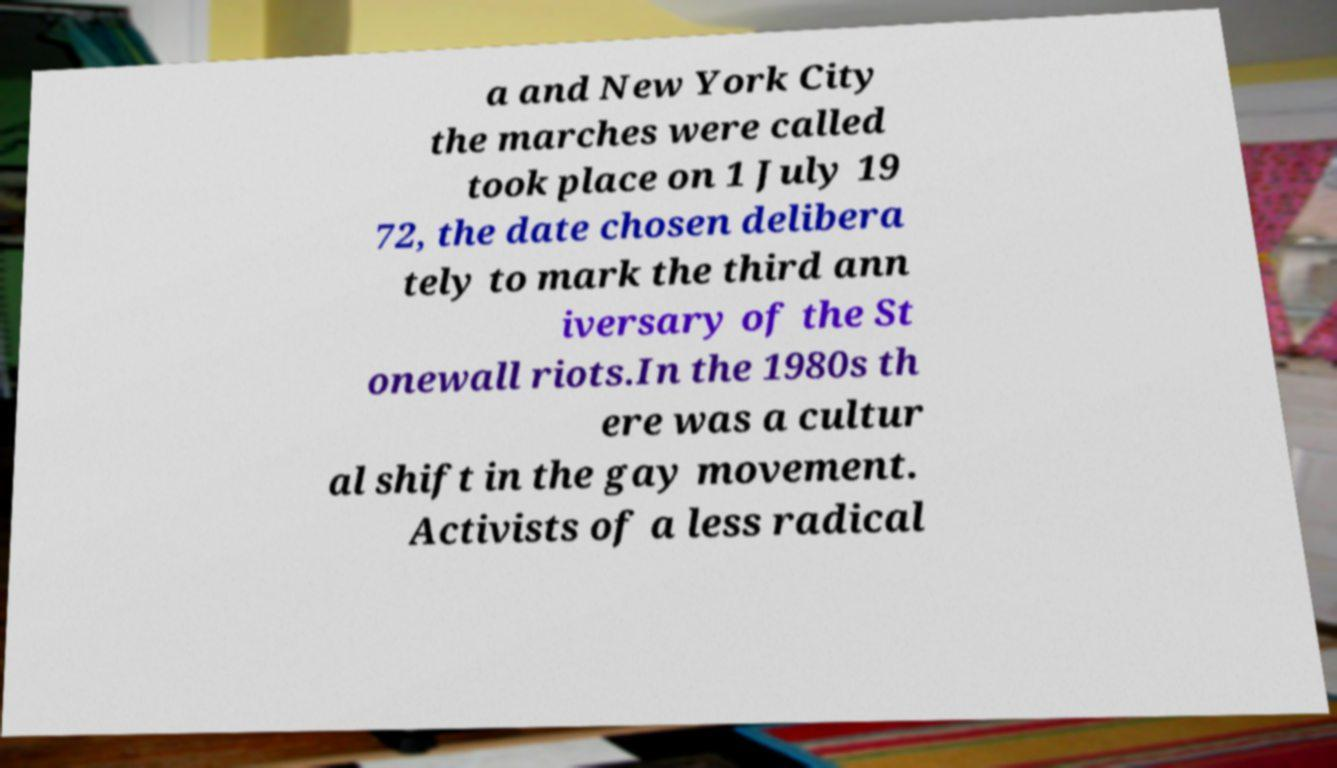Please identify and transcribe the text found in this image. a and New York City the marches were called took place on 1 July 19 72, the date chosen delibera tely to mark the third ann iversary of the St onewall riots.In the 1980s th ere was a cultur al shift in the gay movement. Activists of a less radical 